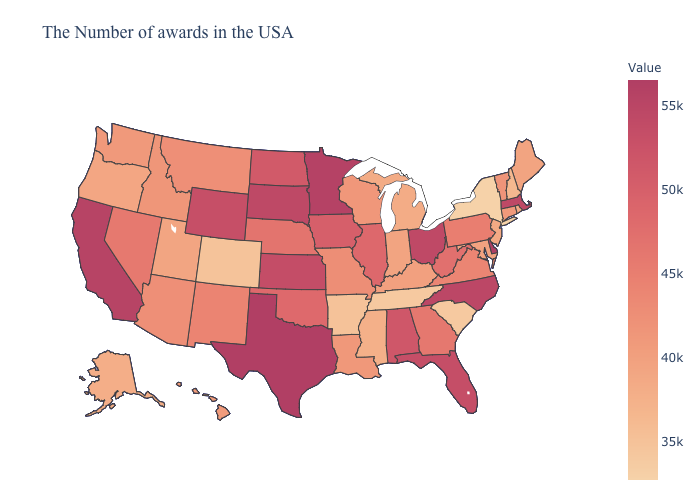Which states have the lowest value in the USA?
Give a very brief answer. New York. Does Kentucky have the lowest value in the USA?
Short answer required. No. Which states have the highest value in the USA?
Be succinct. Texas. Does Colorado have the lowest value in the West?
Keep it brief. Yes. Which states hav the highest value in the MidWest?
Give a very brief answer. Minnesota. Which states hav the highest value in the MidWest?
Concise answer only. Minnesota. 